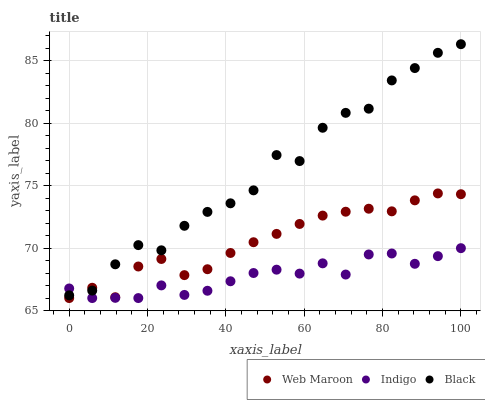Does Indigo have the minimum area under the curve?
Answer yes or no. Yes. Does Black have the maximum area under the curve?
Answer yes or no. Yes. Does Web Maroon have the minimum area under the curve?
Answer yes or no. No. Does Web Maroon have the maximum area under the curve?
Answer yes or no. No. Is Web Maroon the smoothest?
Answer yes or no. Yes. Is Black the roughest?
Answer yes or no. Yes. Is Black the smoothest?
Answer yes or no. No. Is Web Maroon the roughest?
Answer yes or no. No. Does Indigo have the lowest value?
Answer yes or no. Yes. Does Black have the lowest value?
Answer yes or no. No. Does Black have the highest value?
Answer yes or no. Yes. Does Web Maroon have the highest value?
Answer yes or no. No. Does Indigo intersect Black?
Answer yes or no. Yes. Is Indigo less than Black?
Answer yes or no. No. Is Indigo greater than Black?
Answer yes or no. No. 